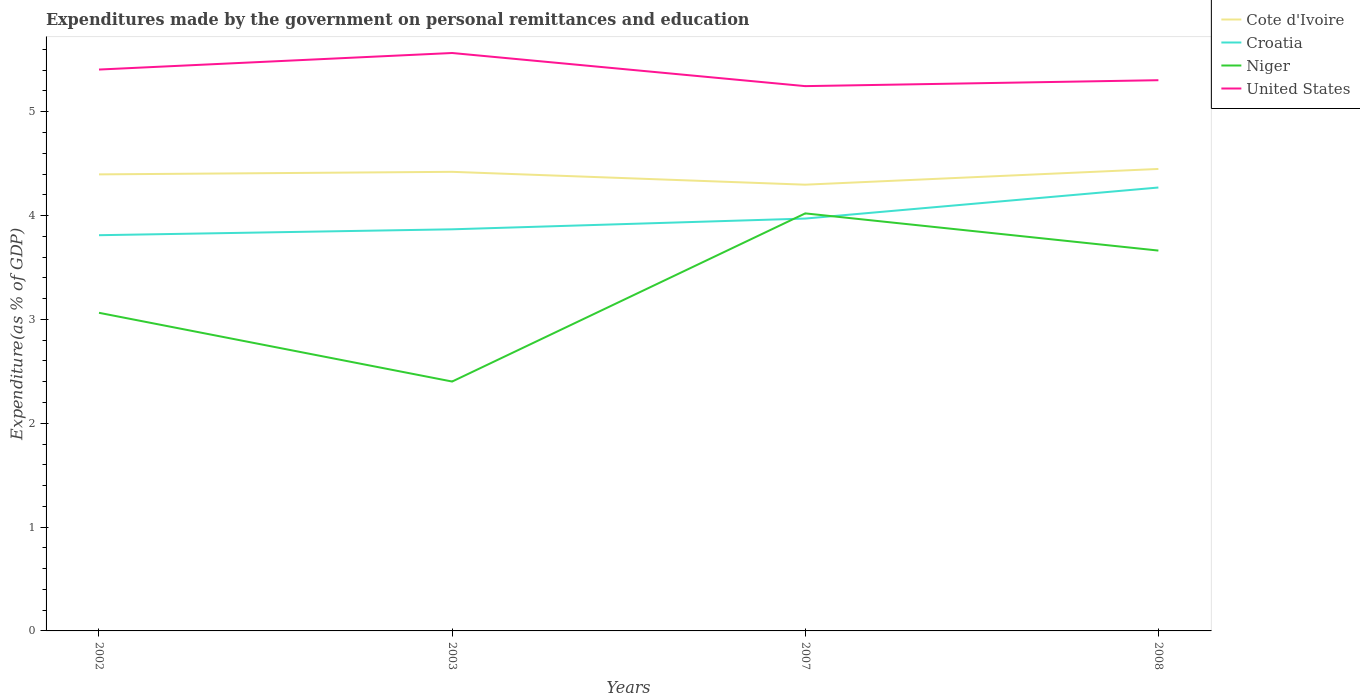How many different coloured lines are there?
Provide a succinct answer. 4. Does the line corresponding to Niger intersect with the line corresponding to United States?
Ensure brevity in your answer.  No. Is the number of lines equal to the number of legend labels?
Offer a very short reply. Yes. Across all years, what is the maximum expenditures made by the government on personal remittances and education in Cote d'Ivoire?
Offer a very short reply. 4.3. What is the total expenditures made by the government on personal remittances and education in Cote d'Ivoire in the graph?
Make the answer very short. 0.12. What is the difference between the highest and the second highest expenditures made by the government on personal remittances and education in United States?
Offer a terse response. 0.32. What is the difference between the highest and the lowest expenditures made by the government on personal remittances and education in United States?
Offer a terse response. 2. Is the expenditures made by the government on personal remittances and education in Cote d'Ivoire strictly greater than the expenditures made by the government on personal remittances and education in Niger over the years?
Give a very brief answer. No. How many lines are there?
Provide a short and direct response. 4. Does the graph contain any zero values?
Offer a very short reply. No. Does the graph contain grids?
Make the answer very short. No. Where does the legend appear in the graph?
Provide a succinct answer. Top right. What is the title of the graph?
Your answer should be compact. Expenditures made by the government on personal remittances and education. What is the label or title of the X-axis?
Make the answer very short. Years. What is the label or title of the Y-axis?
Your answer should be very brief. Expenditure(as % of GDP). What is the Expenditure(as % of GDP) in Cote d'Ivoire in 2002?
Your answer should be very brief. 4.4. What is the Expenditure(as % of GDP) of Croatia in 2002?
Your response must be concise. 3.81. What is the Expenditure(as % of GDP) in Niger in 2002?
Provide a succinct answer. 3.06. What is the Expenditure(as % of GDP) of United States in 2002?
Offer a very short reply. 5.41. What is the Expenditure(as % of GDP) in Cote d'Ivoire in 2003?
Your answer should be very brief. 4.42. What is the Expenditure(as % of GDP) in Croatia in 2003?
Provide a succinct answer. 3.87. What is the Expenditure(as % of GDP) in Niger in 2003?
Your answer should be compact. 2.4. What is the Expenditure(as % of GDP) in United States in 2003?
Provide a short and direct response. 5.57. What is the Expenditure(as % of GDP) of Cote d'Ivoire in 2007?
Make the answer very short. 4.3. What is the Expenditure(as % of GDP) of Croatia in 2007?
Provide a succinct answer. 3.97. What is the Expenditure(as % of GDP) in Niger in 2007?
Offer a very short reply. 4.02. What is the Expenditure(as % of GDP) of United States in 2007?
Your response must be concise. 5.25. What is the Expenditure(as % of GDP) in Cote d'Ivoire in 2008?
Your response must be concise. 4.45. What is the Expenditure(as % of GDP) of Croatia in 2008?
Your answer should be compact. 4.27. What is the Expenditure(as % of GDP) in Niger in 2008?
Offer a terse response. 3.66. What is the Expenditure(as % of GDP) in United States in 2008?
Ensure brevity in your answer.  5.3. Across all years, what is the maximum Expenditure(as % of GDP) in Cote d'Ivoire?
Provide a succinct answer. 4.45. Across all years, what is the maximum Expenditure(as % of GDP) in Croatia?
Offer a very short reply. 4.27. Across all years, what is the maximum Expenditure(as % of GDP) in Niger?
Make the answer very short. 4.02. Across all years, what is the maximum Expenditure(as % of GDP) of United States?
Offer a very short reply. 5.57. Across all years, what is the minimum Expenditure(as % of GDP) in Cote d'Ivoire?
Ensure brevity in your answer.  4.3. Across all years, what is the minimum Expenditure(as % of GDP) in Croatia?
Offer a terse response. 3.81. Across all years, what is the minimum Expenditure(as % of GDP) of Niger?
Provide a succinct answer. 2.4. Across all years, what is the minimum Expenditure(as % of GDP) in United States?
Your answer should be very brief. 5.25. What is the total Expenditure(as % of GDP) of Cote d'Ivoire in the graph?
Give a very brief answer. 17.56. What is the total Expenditure(as % of GDP) of Croatia in the graph?
Give a very brief answer. 15.92. What is the total Expenditure(as % of GDP) of Niger in the graph?
Offer a very short reply. 13.15. What is the total Expenditure(as % of GDP) in United States in the graph?
Provide a short and direct response. 21.52. What is the difference between the Expenditure(as % of GDP) in Cote d'Ivoire in 2002 and that in 2003?
Provide a short and direct response. -0.02. What is the difference between the Expenditure(as % of GDP) of Croatia in 2002 and that in 2003?
Your answer should be very brief. -0.06. What is the difference between the Expenditure(as % of GDP) in Niger in 2002 and that in 2003?
Offer a terse response. 0.66. What is the difference between the Expenditure(as % of GDP) in United States in 2002 and that in 2003?
Offer a terse response. -0.16. What is the difference between the Expenditure(as % of GDP) in Cote d'Ivoire in 2002 and that in 2007?
Keep it short and to the point. 0.1. What is the difference between the Expenditure(as % of GDP) of Croatia in 2002 and that in 2007?
Keep it short and to the point. -0.16. What is the difference between the Expenditure(as % of GDP) of Niger in 2002 and that in 2007?
Offer a very short reply. -0.96. What is the difference between the Expenditure(as % of GDP) of United States in 2002 and that in 2007?
Provide a short and direct response. 0.16. What is the difference between the Expenditure(as % of GDP) in Cote d'Ivoire in 2002 and that in 2008?
Offer a very short reply. -0.05. What is the difference between the Expenditure(as % of GDP) of Croatia in 2002 and that in 2008?
Keep it short and to the point. -0.46. What is the difference between the Expenditure(as % of GDP) in Niger in 2002 and that in 2008?
Your answer should be very brief. -0.6. What is the difference between the Expenditure(as % of GDP) in United States in 2002 and that in 2008?
Make the answer very short. 0.1. What is the difference between the Expenditure(as % of GDP) of Cote d'Ivoire in 2003 and that in 2007?
Keep it short and to the point. 0.12. What is the difference between the Expenditure(as % of GDP) in Croatia in 2003 and that in 2007?
Ensure brevity in your answer.  -0.1. What is the difference between the Expenditure(as % of GDP) in Niger in 2003 and that in 2007?
Ensure brevity in your answer.  -1.62. What is the difference between the Expenditure(as % of GDP) of United States in 2003 and that in 2007?
Ensure brevity in your answer.  0.32. What is the difference between the Expenditure(as % of GDP) in Cote d'Ivoire in 2003 and that in 2008?
Offer a very short reply. -0.03. What is the difference between the Expenditure(as % of GDP) of Croatia in 2003 and that in 2008?
Offer a very short reply. -0.4. What is the difference between the Expenditure(as % of GDP) in Niger in 2003 and that in 2008?
Provide a short and direct response. -1.26. What is the difference between the Expenditure(as % of GDP) in United States in 2003 and that in 2008?
Offer a very short reply. 0.26. What is the difference between the Expenditure(as % of GDP) in Cote d'Ivoire in 2007 and that in 2008?
Keep it short and to the point. -0.15. What is the difference between the Expenditure(as % of GDP) of Croatia in 2007 and that in 2008?
Give a very brief answer. -0.3. What is the difference between the Expenditure(as % of GDP) in Niger in 2007 and that in 2008?
Give a very brief answer. 0.36. What is the difference between the Expenditure(as % of GDP) in United States in 2007 and that in 2008?
Your answer should be compact. -0.06. What is the difference between the Expenditure(as % of GDP) of Cote d'Ivoire in 2002 and the Expenditure(as % of GDP) of Croatia in 2003?
Your answer should be very brief. 0.53. What is the difference between the Expenditure(as % of GDP) in Cote d'Ivoire in 2002 and the Expenditure(as % of GDP) in Niger in 2003?
Offer a very short reply. 2. What is the difference between the Expenditure(as % of GDP) of Cote d'Ivoire in 2002 and the Expenditure(as % of GDP) of United States in 2003?
Ensure brevity in your answer.  -1.17. What is the difference between the Expenditure(as % of GDP) in Croatia in 2002 and the Expenditure(as % of GDP) in Niger in 2003?
Ensure brevity in your answer.  1.41. What is the difference between the Expenditure(as % of GDP) of Croatia in 2002 and the Expenditure(as % of GDP) of United States in 2003?
Offer a terse response. -1.75. What is the difference between the Expenditure(as % of GDP) of Niger in 2002 and the Expenditure(as % of GDP) of United States in 2003?
Make the answer very short. -2.5. What is the difference between the Expenditure(as % of GDP) of Cote d'Ivoire in 2002 and the Expenditure(as % of GDP) of Croatia in 2007?
Make the answer very short. 0.43. What is the difference between the Expenditure(as % of GDP) of Cote d'Ivoire in 2002 and the Expenditure(as % of GDP) of Niger in 2007?
Offer a terse response. 0.38. What is the difference between the Expenditure(as % of GDP) of Cote d'Ivoire in 2002 and the Expenditure(as % of GDP) of United States in 2007?
Give a very brief answer. -0.85. What is the difference between the Expenditure(as % of GDP) in Croatia in 2002 and the Expenditure(as % of GDP) in Niger in 2007?
Give a very brief answer. -0.21. What is the difference between the Expenditure(as % of GDP) of Croatia in 2002 and the Expenditure(as % of GDP) of United States in 2007?
Offer a terse response. -1.44. What is the difference between the Expenditure(as % of GDP) in Niger in 2002 and the Expenditure(as % of GDP) in United States in 2007?
Ensure brevity in your answer.  -2.18. What is the difference between the Expenditure(as % of GDP) in Cote d'Ivoire in 2002 and the Expenditure(as % of GDP) in Croatia in 2008?
Make the answer very short. 0.13. What is the difference between the Expenditure(as % of GDP) in Cote d'Ivoire in 2002 and the Expenditure(as % of GDP) in Niger in 2008?
Offer a very short reply. 0.73. What is the difference between the Expenditure(as % of GDP) of Cote d'Ivoire in 2002 and the Expenditure(as % of GDP) of United States in 2008?
Make the answer very short. -0.91. What is the difference between the Expenditure(as % of GDP) of Croatia in 2002 and the Expenditure(as % of GDP) of Niger in 2008?
Ensure brevity in your answer.  0.15. What is the difference between the Expenditure(as % of GDP) of Croatia in 2002 and the Expenditure(as % of GDP) of United States in 2008?
Your answer should be compact. -1.49. What is the difference between the Expenditure(as % of GDP) in Niger in 2002 and the Expenditure(as % of GDP) in United States in 2008?
Keep it short and to the point. -2.24. What is the difference between the Expenditure(as % of GDP) of Cote d'Ivoire in 2003 and the Expenditure(as % of GDP) of Croatia in 2007?
Your answer should be compact. 0.45. What is the difference between the Expenditure(as % of GDP) in Cote d'Ivoire in 2003 and the Expenditure(as % of GDP) in Niger in 2007?
Your answer should be compact. 0.4. What is the difference between the Expenditure(as % of GDP) in Cote d'Ivoire in 2003 and the Expenditure(as % of GDP) in United States in 2007?
Your answer should be compact. -0.83. What is the difference between the Expenditure(as % of GDP) of Croatia in 2003 and the Expenditure(as % of GDP) of Niger in 2007?
Ensure brevity in your answer.  -0.15. What is the difference between the Expenditure(as % of GDP) in Croatia in 2003 and the Expenditure(as % of GDP) in United States in 2007?
Make the answer very short. -1.38. What is the difference between the Expenditure(as % of GDP) in Niger in 2003 and the Expenditure(as % of GDP) in United States in 2007?
Make the answer very short. -2.84. What is the difference between the Expenditure(as % of GDP) of Cote d'Ivoire in 2003 and the Expenditure(as % of GDP) of Croatia in 2008?
Your answer should be very brief. 0.15. What is the difference between the Expenditure(as % of GDP) in Cote d'Ivoire in 2003 and the Expenditure(as % of GDP) in Niger in 2008?
Ensure brevity in your answer.  0.76. What is the difference between the Expenditure(as % of GDP) in Cote d'Ivoire in 2003 and the Expenditure(as % of GDP) in United States in 2008?
Provide a succinct answer. -0.88. What is the difference between the Expenditure(as % of GDP) of Croatia in 2003 and the Expenditure(as % of GDP) of Niger in 2008?
Ensure brevity in your answer.  0.2. What is the difference between the Expenditure(as % of GDP) in Croatia in 2003 and the Expenditure(as % of GDP) in United States in 2008?
Your response must be concise. -1.44. What is the difference between the Expenditure(as % of GDP) of Niger in 2003 and the Expenditure(as % of GDP) of United States in 2008?
Provide a short and direct response. -2.9. What is the difference between the Expenditure(as % of GDP) in Cote d'Ivoire in 2007 and the Expenditure(as % of GDP) in Croatia in 2008?
Keep it short and to the point. 0.03. What is the difference between the Expenditure(as % of GDP) in Cote d'Ivoire in 2007 and the Expenditure(as % of GDP) in Niger in 2008?
Give a very brief answer. 0.63. What is the difference between the Expenditure(as % of GDP) in Cote d'Ivoire in 2007 and the Expenditure(as % of GDP) in United States in 2008?
Your answer should be compact. -1.01. What is the difference between the Expenditure(as % of GDP) in Croatia in 2007 and the Expenditure(as % of GDP) in Niger in 2008?
Your answer should be very brief. 0.31. What is the difference between the Expenditure(as % of GDP) of Croatia in 2007 and the Expenditure(as % of GDP) of United States in 2008?
Provide a succinct answer. -1.33. What is the difference between the Expenditure(as % of GDP) in Niger in 2007 and the Expenditure(as % of GDP) in United States in 2008?
Give a very brief answer. -1.28. What is the average Expenditure(as % of GDP) in Cote d'Ivoire per year?
Keep it short and to the point. 4.39. What is the average Expenditure(as % of GDP) in Croatia per year?
Provide a short and direct response. 3.98. What is the average Expenditure(as % of GDP) of Niger per year?
Provide a succinct answer. 3.29. What is the average Expenditure(as % of GDP) of United States per year?
Your answer should be very brief. 5.38. In the year 2002, what is the difference between the Expenditure(as % of GDP) in Cote d'Ivoire and Expenditure(as % of GDP) in Croatia?
Keep it short and to the point. 0.59. In the year 2002, what is the difference between the Expenditure(as % of GDP) in Cote d'Ivoire and Expenditure(as % of GDP) in Niger?
Make the answer very short. 1.33. In the year 2002, what is the difference between the Expenditure(as % of GDP) in Cote d'Ivoire and Expenditure(as % of GDP) in United States?
Keep it short and to the point. -1.01. In the year 2002, what is the difference between the Expenditure(as % of GDP) of Croatia and Expenditure(as % of GDP) of Niger?
Provide a short and direct response. 0.75. In the year 2002, what is the difference between the Expenditure(as % of GDP) in Croatia and Expenditure(as % of GDP) in United States?
Your answer should be compact. -1.6. In the year 2002, what is the difference between the Expenditure(as % of GDP) of Niger and Expenditure(as % of GDP) of United States?
Your answer should be compact. -2.34. In the year 2003, what is the difference between the Expenditure(as % of GDP) of Cote d'Ivoire and Expenditure(as % of GDP) of Croatia?
Ensure brevity in your answer.  0.55. In the year 2003, what is the difference between the Expenditure(as % of GDP) of Cote d'Ivoire and Expenditure(as % of GDP) of Niger?
Offer a very short reply. 2.02. In the year 2003, what is the difference between the Expenditure(as % of GDP) of Cote d'Ivoire and Expenditure(as % of GDP) of United States?
Your answer should be compact. -1.14. In the year 2003, what is the difference between the Expenditure(as % of GDP) of Croatia and Expenditure(as % of GDP) of Niger?
Ensure brevity in your answer.  1.47. In the year 2003, what is the difference between the Expenditure(as % of GDP) in Croatia and Expenditure(as % of GDP) in United States?
Your response must be concise. -1.7. In the year 2003, what is the difference between the Expenditure(as % of GDP) in Niger and Expenditure(as % of GDP) in United States?
Offer a terse response. -3.16. In the year 2007, what is the difference between the Expenditure(as % of GDP) in Cote d'Ivoire and Expenditure(as % of GDP) in Croatia?
Provide a short and direct response. 0.33. In the year 2007, what is the difference between the Expenditure(as % of GDP) of Cote d'Ivoire and Expenditure(as % of GDP) of Niger?
Give a very brief answer. 0.28. In the year 2007, what is the difference between the Expenditure(as % of GDP) in Cote d'Ivoire and Expenditure(as % of GDP) in United States?
Ensure brevity in your answer.  -0.95. In the year 2007, what is the difference between the Expenditure(as % of GDP) of Croatia and Expenditure(as % of GDP) of Niger?
Your answer should be compact. -0.05. In the year 2007, what is the difference between the Expenditure(as % of GDP) in Croatia and Expenditure(as % of GDP) in United States?
Give a very brief answer. -1.28. In the year 2007, what is the difference between the Expenditure(as % of GDP) of Niger and Expenditure(as % of GDP) of United States?
Ensure brevity in your answer.  -1.23. In the year 2008, what is the difference between the Expenditure(as % of GDP) in Cote d'Ivoire and Expenditure(as % of GDP) in Croatia?
Provide a short and direct response. 0.18. In the year 2008, what is the difference between the Expenditure(as % of GDP) of Cote d'Ivoire and Expenditure(as % of GDP) of Niger?
Offer a terse response. 0.79. In the year 2008, what is the difference between the Expenditure(as % of GDP) in Cote d'Ivoire and Expenditure(as % of GDP) in United States?
Your answer should be very brief. -0.85. In the year 2008, what is the difference between the Expenditure(as % of GDP) of Croatia and Expenditure(as % of GDP) of Niger?
Offer a very short reply. 0.61. In the year 2008, what is the difference between the Expenditure(as % of GDP) in Croatia and Expenditure(as % of GDP) in United States?
Offer a terse response. -1.03. In the year 2008, what is the difference between the Expenditure(as % of GDP) in Niger and Expenditure(as % of GDP) in United States?
Make the answer very short. -1.64. What is the ratio of the Expenditure(as % of GDP) of Cote d'Ivoire in 2002 to that in 2003?
Your answer should be very brief. 0.99. What is the ratio of the Expenditure(as % of GDP) of Croatia in 2002 to that in 2003?
Offer a very short reply. 0.99. What is the ratio of the Expenditure(as % of GDP) in Niger in 2002 to that in 2003?
Give a very brief answer. 1.28. What is the ratio of the Expenditure(as % of GDP) of United States in 2002 to that in 2003?
Make the answer very short. 0.97. What is the ratio of the Expenditure(as % of GDP) of Cote d'Ivoire in 2002 to that in 2007?
Provide a short and direct response. 1.02. What is the ratio of the Expenditure(as % of GDP) in Croatia in 2002 to that in 2007?
Make the answer very short. 0.96. What is the ratio of the Expenditure(as % of GDP) of Niger in 2002 to that in 2007?
Your answer should be very brief. 0.76. What is the ratio of the Expenditure(as % of GDP) in United States in 2002 to that in 2007?
Provide a succinct answer. 1.03. What is the ratio of the Expenditure(as % of GDP) of Croatia in 2002 to that in 2008?
Your answer should be compact. 0.89. What is the ratio of the Expenditure(as % of GDP) of Niger in 2002 to that in 2008?
Keep it short and to the point. 0.84. What is the ratio of the Expenditure(as % of GDP) of United States in 2002 to that in 2008?
Ensure brevity in your answer.  1.02. What is the ratio of the Expenditure(as % of GDP) in Cote d'Ivoire in 2003 to that in 2007?
Give a very brief answer. 1.03. What is the ratio of the Expenditure(as % of GDP) in Croatia in 2003 to that in 2007?
Provide a succinct answer. 0.97. What is the ratio of the Expenditure(as % of GDP) of Niger in 2003 to that in 2007?
Keep it short and to the point. 0.6. What is the ratio of the Expenditure(as % of GDP) of United States in 2003 to that in 2007?
Your answer should be very brief. 1.06. What is the ratio of the Expenditure(as % of GDP) in Cote d'Ivoire in 2003 to that in 2008?
Your answer should be very brief. 0.99. What is the ratio of the Expenditure(as % of GDP) in Croatia in 2003 to that in 2008?
Make the answer very short. 0.91. What is the ratio of the Expenditure(as % of GDP) of Niger in 2003 to that in 2008?
Keep it short and to the point. 0.66. What is the ratio of the Expenditure(as % of GDP) of United States in 2003 to that in 2008?
Offer a very short reply. 1.05. What is the ratio of the Expenditure(as % of GDP) in Cote d'Ivoire in 2007 to that in 2008?
Provide a succinct answer. 0.97. What is the ratio of the Expenditure(as % of GDP) of Croatia in 2007 to that in 2008?
Your response must be concise. 0.93. What is the ratio of the Expenditure(as % of GDP) of Niger in 2007 to that in 2008?
Provide a succinct answer. 1.1. What is the ratio of the Expenditure(as % of GDP) of United States in 2007 to that in 2008?
Give a very brief answer. 0.99. What is the difference between the highest and the second highest Expenditure(as % of GDP) in Cote d'Ivoire?
Keep it short and to the point. 0.03. What is the difference between the highest and the second highest Expenditure(as % of GDP) of Croatia?
Your response must be concise. 0.3. What is the difference between the highest and the second highest Expenditure(as % of GDP) of Niger?
Offer a very short reply. 0.36. What is the difference between the highest and the second highest Expenditure(as % of GDP) in United States?
Your answer should be very brief. 0.16. What is the difference between the highest and the lowest Expenditure(as % of GDP) of Cote d'Ivoire?
Ensure brevity in your answer.  0.15. What is the difference between the highest and the lowest Expenditure(as % of GDP) of Croatia?
Offer a very short reply. 0.46. What is the difference between the highest and the lowest Expenditure(as % of GDP) in Niger?
Your response must be concise. 1.62. What is the difference between the highest and the lowest Expenditure(as % of GDP) of United States?
Ensure brevity in your answer.  0.32. 